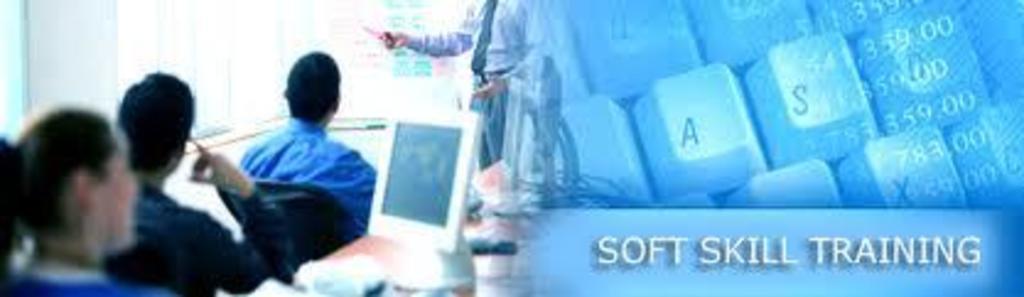Describe this image in one or two sentences. On the right side of the image we can see keyboard and text. On the left side of the image we can see computer and persons. 